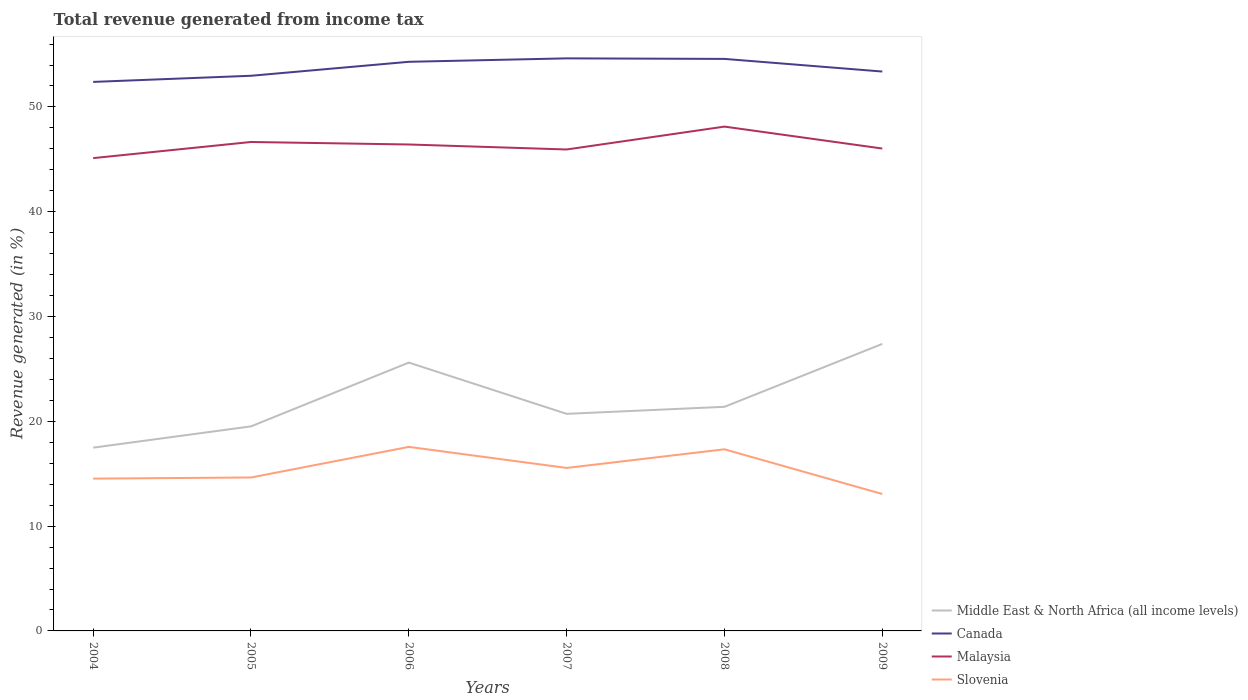How many different coloured lines are there?
Your answer should be compact. 4. Across all years, what is the maximum total revenue generated in Malaysia?
Your answer should be compact. 45.12. What is the total total revenue generated in Middle East & North Africa (all income levels) in the graph?
Ensure brevity in your answer.  -2.03. What is the difference between the highest and the second highest total revenue generated in Canada?
Keep it short and to the point. 2.25. What is the difference between the highest and the lowest total revenue generated in Canada?
Your response must be concise. 3. Is the total revenue generated in Malaysia strictly greater than the total revenue generated in Slovenia over the years?
Ensure brevity in your answer.  No. How many lines are there?
Offer a very short reply. 4. How many years are there in the graph?
Make the answer very short. 6. Are the values on the major ticks of Y-axis written in scientific E-notation?
Offer a very short reply. No. What is the title of the graph?
Offer a very short reply. Total revenue generated from income tax. What is the label or title of the Y-axis?
Keep it short and to the point. Revenue generated (in %). What is the Revenue generated (in %) in Middle East & North Africa (all income levels) in 2004?
Provide a short and direct response. 17.49. What is the Revenue generated (in %) of Canada in 2004?
Your response must be concise. 52.39. What is the Revenue generated (in %) in Malaysia in 2004?
Give a very brief answer. 45.12. What is the Revenue generated (in %) of Slovenia in 2004?
Keep it short and to the point. 14.53. What is the Revenue generated (in %) in Middle East & North Africa (all income levels) in 2005?
Make the answer very short. 19.52. What is the Revenue generated (in %) of Canada in 2005?
Your answer should be very brief. 52.97. What is the Revenue generated (in %) of Malaysia in 2005?
Ensure brevity in your answer.  46.66. What is the Revenue generated (in %) in Slovenia in 2005?
Your answer should be very brief. 14.64. What is the Revenue generated (in %) in Middle East & North Africa (all income levels) in 2006?
Make the answer very short. 25.61. What is the Revenue generated (in %) of Canada in 2006?
Make the answer very short. 54.31. What is the Revenue generated (in %) in Malaysia in 2006?
Offer a terse response. 46.42. What is the Revenue generated (in %) in Slovenia in 2006?
Your response must be concise. 17.56. What is the Revenue generated (in %) of Middle East & North Africa (all income levels) in 2007?
Provide a succinct answer. 20.71. What is the Revenue generated (in %) of Canada in 2007?
Make the answer very short. 54.64. What is the Revenue generated (in %) of Malaysia in 2007?
Your response must be concise. 45.94. What is the Revenue generated (in %) in Slovenia in 2007?
Give a very brief answer. 15.55. What is the Revenue generated (in %) of Middle East & North Africa (all income levels) in 2008?
Offer a very short reply. 21.38. What is the Revenue generated (in %) in Canada in 2008?
Give a very brief answer. 54.58. What is the Revenue generated (in %) of Malaysia in 2008?
Offer a very short reply. 48.12. What is the Revenue generated (in %) in Slovenia in 2008?
Offer a terse response. 17.33. What is the Revenue generated (in %) of Middle East & North Africa (all income levels) in 2009?
Your answer should be compact. 27.39. What is the Revenue generated (in %) of Canada in 2009?
Provide a succinct answer. 53.38. What is the Revenue generated (in %) in Malaysia in 2009?
Ensure brevity in your answer.  46.03. What is the Revenue generated (in %) in Slovenia in 2009?
Provide a succinct answer. 13.06. Across all years, what is the maximum Revenue generated (in %) of Middle East & North Africa (all income levels)?
Offer a terse response. 27.39. Across all years, what is the maximum Revenue generated (in %) of Canada?
Your response must be concise. 54.64. Across all years, what is the maximum Revenue generated (in %) of Malaysia?
Provide a short and direct response. 48.12. Across all years, what is the maximum Revenue generated (in %) in Slovenia?
Offer a terse response. 17.56. Across all years, what is the minimum Revenue generated (in %) in Middle East & North Africa (all income levels)?
Give a very brief answer. 17.49. Across all years, what is the minimum Revenue generated (in %) in Canada?
Ensure brevity in your answer.  52.39. Across all years, what is the minimum Revenue generated (in %) of Malaysia?
Give a very brief answer. 45.12. Across all years, what is the minimum Revenue generated (in %) in Slovenia?
Ensure brevity in your answer.  13.06. What is the total Revenue generated (in %) of Middle East & North Africa (all income levels) in the graph?
Make the answer very short. 132.1. What is the total Revenue generated (in %) of Canada in the graph?
Ensure brevity in your answer.  322.26. What is the total Revenue generated (in %) of Malaysia in the graph?
Give a very brief answer. 278.28. What is the total Revenue generated (in %) of Slovenia in the graph?
Provide a short and direct response. 92.68. What is the difference between the Revenue generated (in %) in Middle East & North Africa (all income levels) in 2004 and that in 2005?
Provide a short and direct response. -2.03. What is the difference between the Revenue generated (in %) in Canada in 2004 and that in 2005?
Give a very brief answer. -0.59. What is the difference between the Revenue generated (in %) of Malaysia in 2004 and that in 2005?
Ensure brevity in your answer.  -1.54. What is the difference between the Revenue generated (in %) of Slovenia in 2004 and that in 2005?
Offer a terse response. -0.11. What is the difference between the Revenue generated (in %) of Middle East & North Africa (all income levels) in 2004 and that in 2006?
Your response must be concise. -8.12. What is the difference between the Revenue generated (in %) of Canada in 2004 and that in 2006?
Your response must be concise. -1.92. What is the difference between the Revenue generated (in %) of Malaysia in 2004 and that in 2006?
Keep it short and to the point. -1.3. What is the difference between the Revenue generated (in %) in Slovenia in 2004 and that in 2006?
Give a very brief answer. -3.03. What is the difference between the Revenue generated (in %) of Middle East & North Africa (all income levels) in 2004 and that in 2007?
Keep it short and to the point. -3.23. What is the difference between the Revenue generated (in %) of Canada in 2004 and that in 2007?
Provide a succinct answer. -2.25. What is the difference between the Revenue generated (in %) of Malaysia in 2004 and that in 2007?
Keep it short and to the point. -0.82. What is the difference between the Revenue generated (in %) of Slovenia in 2004 and that in 2007?
Keep it short and to the point. -1.02. What is the difference between the Revenue generated (in %) in Middle East & North Africa (all income levels) in 2004 and that in 2008?
Provide a succinct answer. -3.9. What is the difference between the Revenue generated (in %) in Canada in 2004 and that in 2008?
Offer a very short reply. -2.19. What is the difference between the Revenue generated (in %) in Malaysia in 2004 and that in 2008?
Provide a succinct answer. -3.01. What is the difference between the Revenue generated (in %) in Slovenia in 2004 and that in 2008?
Give a very brief answer. -2.8. What is the difference between the Revenue generated (in %) in Middle East & North Africa (all income levels) in 2004 and that in 2009?
Ensure brevity in your answer.  -9.9. What is the difference between the Revenue generated (in %) of Canada in 2004 and that in 2009?
Offer a very short reply. -0.99. What is the difference between the Revenue generated (in %) in Malaysia in 2004 and that in 2009?
Provide a short and direct response. -0.91. What is the difference between the Revenue generated (in %) in Slovenia in 2004 and that in 2009?
Your answer should be compact. 1.47. What is the difference between the Revenue generated (in %) of Middle East & North Africa (all income levels) in 2005 and that in 2006?
Ensure brevity in your answer.  -6.09. What is the difference between the Revenue generated (in %) of Canada in 2005 and that in 2006?
Ensure brevity in your answer.  -1.33. What is the difference between the Revenue generated (in %) of Malaysia in 2005 and that in 2006?
Give a very brief answer. 0.24. What is the difference between the Revenue generated (in %) in Slovenia in 2005 and that in 2006?
Ensure brevity in your answer.  -2.92. What is the difference between the Revenue generated (in %) of Middle East & North Africa (all income levels) in 2005 and that in 2007?
Your response must be concise. -1.2. What is the difference between the Revenue generated (in %) of Canada in 2005 and that in 2007?
Provide a succinct answer. -1.66. What is the difference between the Revenue generated (in %) in Malaysia in 2005 and that in 2007?
Provide a succinct answer. 0.72. What is the difference between the Revenue generated (in %) in Slovenia in 2005 and that in 2007?
Offer a terse response. -0.91. What is the difference between the Revenue generated (in %) of Middle East & North Africa (all income levels) in 2005 and that in 2008?
Keep it short and to the point. -1.87. What is the difference between the Revenue generated (in %) in Canada in 2005 and that in 2008?
Provide a short and direct response. -1.61. What is the difference between the Revenue generated (in %) of Malaysia in 2005 and that in 2008?
Provide a succinct answer. -1.47. What is the difference between the Revenue generated (in %) of Slovenia in 2005 and that in 2008?
Make the answer very short. -2.69. What is the difference between the Revenue generated (in %) in Middle East & North Africa (all income levels) in 2005 and that in 2009?
Your response must be concise. -7.87. What is the difference between the Revenue generated (in %) in Canada in 2005 and that in 2009?
Offer a very short reply. -0.4. What is the difference between the Revenue generated (in %) in Malaysia in 2005 and that in 2009?
Give a very brief answer. 0.63. What is the difference between the Revenue generated (in %) in Slovenia in 2005 and that in 2009?
Provide a short and direct response. 1.58. What is the difference between the Revenue generated (in %) in Middle East & North Africa (all income levels) in 2006 and that in 2007?
Offer a very short reply. 4.89. What is the difference between the Revenue generated (in %) of Canada in 2006 and that in 2007?
Provide a succinct answer. -0.33. What is the difference between the Revenue generated (in %) of Malaysia in 2006 and that in 2007?
Keep it short and to the point. 0.48. What is the difference between the Revenue generated (in %) of Slovenia in 2006 and that in 2007?
Make the answer very short. 2.01. What is the difference between the Revenue generated (in %) in Middle East & North Africa (all income levels) in 2006 and that in 2008?
Provide a succinct answer. 4.22. What is the difference between the Revenue generated (in %) of Canada in 2006 and that in 2008?
Ensure brevity in your answer.  -0.28. What is the difference between the Revenue generated (in %) of Malaysia in 2006 and that in 2008?
Offer a very short reply. -1.71. What is the difference between the Revenue generated (in %) in Slovenia in 2006 and that in 2008?
Provide a succinct answer. 0.23. What is the difference between the Revenue generated (in %) of Middle East & North Africa (all income levels) in 2006 and that in 2009?
Provide a succinct answer. -1.78. What is the difference between the Revenue generated (in %) of Canada in 2006 and that in 2009?
Your response must be concise. 0.93. What is the difference between the Revenue generated (in %) in Malaysia in 2006 and that in 2009?
Give a very brief answer. 0.39. What is the difference between the Revenue generated (in %) in Slovenia in 2006 and that in 2009?
Provide a short and direct response. 4.5. What is the difference between the Revenue generated (in %) of Middle East & North Africa (all income levels) in 2007 and that in 2008?
Make the answer very short. -0.67. What is the difference between the Revenue generated (in %) in Canada in 2007 and that in 2008?
Your answer should be compact. 0.05. What is the difference between the Revenue generated (in %) in Malaysia in 2007 and that in 2008?
Offer a terse response. -2.18. What is the difference between the Revenue generated (in %) in Slovenia in 2007 and that in 2008?
Provide a succinct answer. -1.78. What is the difference between the Revenue generated (in %) in Middle East & North Africa (all income levels) in 2007 and that in 2009?
Make the answer very short. -6.67. What is the difference between the Revenue generated (in %) in Canada in 2007 and that in 2009?
Ensure brevity in your answer.  1.26. What is the difference between the Revenue generated (in %) in Malaysia in 2007 and that in 2009?
Make the answer very short. -0.09. What is the difference between the Revenue generated (in %) of Slovenia in 2007 and that in 2009?
Provide a succinct answer. 2.49. What is the difference between the Revenue generated (in %) of Middle East & North Africa (all income levels) in 2008 and that in 2009?
Make the answer very short. -6. What is the difference between the Revenue generated (in %) in Canada in 2008 and that in 2009?
Provide a succinct answer. 1.21. What is the difference between the Revenue generated (in %) in Malaysia in 2008 and that in 2009?
Provide a short and direct response. 2.09. What is the difference between the Revenue generated (in %) in Slovenia in 2008 and that in 2009?
Your answer should be compact. 4.27. What is the difference between the Revenue generated (in %) of Middle East & North Africa (all income levels) in 2004 and the Revenue generated (in %) of Canada in 2005?
Keep it short and to the point. -35.49. What is the difference between the Revenue generated (in %) of Middle East & North Africa (all income levels) in 2004 and the Revenue generated (in %) of Malaysia in 2005?
Provide a succinct answer. -29.17. What is the difference between the Revenue generated (in %) of Middle East & North Africa (all income levels) in 2004 and the Revenue generated (in %) of Slovenia in 2005?
Your answer should be compact. 2.85. What is the difference between the Revenue generated (in %) of Canada in 2004 and the Revenue generated (in %) of Malaysia in 2005?
Your response must be concise. 5.73. What is the difference between the Revenue generated (in %) in Canada in 2004 and the Revenue generated (in %) in Slovenia in 2005?
Offer a terse response. 37.75. What is the difference between the Revenue generated (in %) of Malaysia in 2004 and the Revenue generated (in %) of Slovenia in 2005?
Provide a short and direct response. 30.47. What is the difference between the Revenue generated (in %) of Middle East & North Africa (all income levels) in 2004 and the Revenue generated (in %) of Canada in 2006?
Offer a very short reply. -36.82. What is the difference between the Revenue generated (in %) in Middle East & North Africa (all income levels) in 2004 and the Revenue generated (in %) in Malaysia in 2006?
Offer a very short reply. -28.93. What is the difference between the Revenue generated (in %) in Middle East & North Africa (all income levels) in 2004 and the Revenue generated (in %) in Slovenia in 2006?
Your answer should be compact. -0.07. What is the difference between the Revenue generated (in %) of Canada in 2004 and the Revenue generated (in %) of Malaysia in 2006?
Offer a terse response. 5.97. What is the difference between the Revenue generated (in %) of Canada in 2004 and the Revenue generated (in %) of Slovenia in 2006?
Provide a succinct answer. 34.83. What is the difference between the Revenue generated (in %) of Malaysia in 2004 and the Revenue generated (in %) of Slovenia in 2006?
Offer a very short reply. 27.55. What is the difference between the Revenue generated (in %) in Middle East & North Africa (all income levels) in 2004 and the Revenue generated (in %) in Canada in 2007?
Your answer should be very brief. -37.15. What is the difference between the Revenue generated (in %) in Middle East & North Africa (all income levels) in 2004 and the Revenue generated (in %) in Malaysia in 2007?
Give a very brief answer. -28.45. What is the difference between the Revenue generated (in %) of Middle East & North Africa (all income levels) in 2004 and the Revenue generated (in %) of Slovenia in 2007?
Give a very brief answer. 1.94. What is the difference between the Revenue generated (in %) of Canada in 2004 and the Revenue generated (in %) of Malaysia in 2007?
Offer a terse response. 6.45. What is the difference between the Revenue generated (in %) in Canada in 2004 and the Revenue generated (in %) in Slovenia in 2007?
Provide a succinct answer. 36.84. What is the difference between the Revenue generated (in %) in Malaysia in 2004 and the Revenue generated (in %) in Slovenia in 2007?
Give a very brief answer. 29.56. What is the difference between the Revenue generated (in %) in Middle East & North Africa (all income levels) in 2004 and the Revenue generated (in %) in Canada in 2008?
Give a very brief answer. -37.1. What is the difference between the Revenue generated (in %) in Middle East & North Africa (all income levels) in 2004 and the Revenue generated (in %) in Malaysia in 2008?
Ensure brevity in your answer.  -30.64. What is the difference between the Revenue generated (in %) in Middle East & North Africa (all income levels) in 2004 and the Revenue generated (in %) in Slovenia in 2008?
Your answer should be very brief. 0.16. What is the difference between the Revenue generated (in %) in Canada in 2004 and the Revenue generated (in %) in Malaysia in 2008?
Ensure brevity in your answer.  4.26. What is the difference between the Revenue generated (in %) in Canada in 2004 and the Revenue generated (in %) in Slovenia in 2008?
Provide a short and direct response. 35.06. What is the difference between the Revenue generated (in %) of Malaysia in 2004 and the Revenue generated (in %) of Slovenia in 2008?
Ensure brevity in your answer.  27.78. What is the difference between the Revenue generated (in %) in Middle East & North Africa (all income levels) in 2004 and the Revenue generated (in %) in Canada in 2009?
Make the answer very short. -35.89. What is the difference between the Revenue generated (in %) in Middle East & North Africa (all income levels) in 2004 and the Revenue generated (in %) in Malaysia in 2009?
Ensure brevity in your answer.  -28.54. What is the difference between the Revenue generated (in %) in Middle East & North Africa (all income levels) in 2004 and the Revenue generated (in %) in Slovenia in 2009?
Your answer should be compact. 4.42. What is the difference between the Revenue generated (in %) of Canada in 2004 and the Revenue generated (in %) of Malaysia in 2009?
Your answer should be compact. 6.36. What is the difference between the Revenue generated (in %) in Canada in 2004 and the Revenue generated (in %) in Slovenia in 2009?
Provide a short and direct response. 39.32. What is the difference between the Revenue generated (in %) in Malaysia in 2004 and the Revenue generated (in %) in Slovenia in 2009?
Your answer should be compact. 32.05. What is the difference between the Revenue generated (in %) in Middle East & North Africa (all income levels) in 2005 and the Revenue generated (in %) in Canada in 2006?
Your response must be concise. -34.79. What is the difference between the Revenue generated (in %) in Middle East & North Africa (all income levels) in 2005 and the Revenue generated (in %) in Malaysia in 2006?
Offer a very short reply. -26.9. What is the difference between the Revenue generated (in %) of Middle East & North Africa (all income levels) in 2005 and the Revenue generated (in %) of Slovenia in 2006?
Make the answer very short. 1.96. What is the difference between the Revenue generated (in %) of Canada in 2005 and the Revenue generated (in %) of Malaysia in 2006?
Ensure brevity in your answer.  6.56. What is the difference between the Revenue generated (in %) in Canada in 2005 and the Revenue generated (in %) in Slovenia in 2006?
Your answer should be very brief. 35.41. What is the difference between the Revenue generated (in %) in Malaysia in 2005 and the Revenue generated (in %) in Slovenia in 2006?
Your response must be concise. 29.09. What is the difference between the Revenue generated (in %) of Middle East & North Africa (all income levels) in 2005 and the Revenue generated (in %) of Canada in 2007?
Offer a very short reply. -35.12. What is the difference between the Revenue generated (in %) of Middle East & North Africa (all income levels) in 2005 and the Revenue generated (in %) of Malaysia in 2007?
Offer a terse response. -26.42. What is the difference between the Revenue generated (in %) in Middle East & North Africa (all income levels) in 2005 and the Revenue generated (in %) in Slovenia in 2007?
Your answer should be compact. 3.96. What is the difference between the Revenue generated (in %) of Canada in 2005 and the Revenue generated (in %) of Malaysia in 2007?
Your answer should be very brief. 7.03. What is the difference between the Revenue generated (in %) of Canada in 2005 and the Revenue generated (in %) of Slovenia in 2007?
Offer a terse response. 37.42. What is the difference between the Revenue generated (in %) of Malaysia in 2005 and the Revenue generated (in %) of Slovenia in 2007?
Make the answer very short. 31.1. What is the difference between the Revenue generated (in %) in Middle East & North Africa (all income levels) in 2005 and the Revenue generated (in %) in Canada in 2008?
Ensure brevity in your answer.  -35.07. What is the difference between the Revenue generated (in %) of Middle East & North Africa (all income levels) in 2005 and the Revenue generated (in %) of Malaysia in 2008?
Keep it short and to the point. -28.61. What is the difference between the Revenue generated (in %) of Middle East & North Africa (all income levels) in 2005 and the Revenue generated (in %) of Slovenia in 2008?
Provide a succinct answer. 2.19. What is the difference between the Revenue generated (in %) of Canada in 2005 and the Revenue generated (in %) of Malaysia in 2008?
Make the answer very short. 4.85. What is the difference between the Revenue generated (in %) of Canada in 2005 and the Revenue generated (in %) of Slovenia in 2008?
Provide a succinct answer. 35.64. What is the difference between the Revenue generated (in %) in Malaysia in 2005 and the Revenue generated (in %) in Slovenia in 2008?
Your response must be concise. 29.32. What is the difference between the Revenue generated (in %) of Middle East & North Africa (all income levels) in 2005 and the Revenue generated (in %) of Canada in 2009?
Offer a very short reply. -33.86. What is the difference between the Revenue generated (in %) in Middle East & North Africa (all income levels) in 2005 and the Revenue generated (in %) in Malaysia in 2009?
Ensure brevity in your answer.  -26.51. What is the difference between the Revenue generated (in %) of Middle East & North Africa (all income levels) in 2005 and the Revenue generated (in %) of Slovenia in 2009?
Ensure brevity in your answer.  6.45. What is the difference between the Revenue generated (in %) in Canada in 2005 and the Revenue generated (in %) in Malaysia in 2009?
Give a very brief answer. 6.94. What is the difference between the Revenue generated (in %) in Canada in 2005 and the Revenue generated (in %) in Slovenia in 2009?
Your response must be concise. 39.91. What is the difference between the Revenue generated (in %) of Malaysia in 2005 and the Revenue generated (in %) of Slovenia in 2009?
Your answer should be compact. 33.59. What is the difference between the Revenue generated (in %) of Middle East & North Africa (all income levels) in 2006 and the Revenue generated (in %) of Canada in 2007?
Provide a short and direct response. -29.03. What is the difference between the Revenue generated (in %) of Middle East & North Africa (all income levels) in 2006 and the Revenue generated (in %) of Malaysia in 2007?
Make the answer very short. -20.33. What is the difference between the Revenue generated (in %) of Middle East & North Africa (all income levels) in 2006 and the Revenue generated (in %) of Slovenia in 2007?
Your answer should be compact. 10.05. What is the difference between the Revenue generated (in %) in Canada in 2006 and the Revenue generated (in %) in Malaysia in 2007?
Offer a terse response. 8.37. What is the difference between the Revenue generated (in %) of Canada in 2006 and the Revenue generated (in %) of Slovenia in 2007?
Your answer should be very brief. 38.75. What is the difference between the Revenue generated (in %) in Malaysia in 2006 and the Revenue generated (in %) in Slovenia in 2007?
Provide a succinct answer. 30.86. What is the difference between the Revenue generated (in %) of Middle East & North Africa (all income levels) in 2006 and the Revenue generated (in %) of Canada in 2008?
Make the answer very short. -28.98. What is the difference between the Revenue generated (in %) of Middle East & North Africa (all income levels) in 2006 and the Revenue generated (in %) of Malaysia in 2008?
Provide a succinct answer. -22.52. What is the difference between the Revenue generated (in %) of Middle East & North Africa (all income levels) in 2006 and the Revenue generated (in %) of Slovenia in 2008?
Give a very brief answer. 8.27. What is the difference between the Revenue generated (in %) of Canada in 2006 and the Revenue generated (in %) of Malaysia in 2008?
Ensure brevity in your answer.  6.18. What is the difference between the Revenue generated (in %) in Canada in 2006 and the Revenue generated (in %) in Slovenia in 2008?
Your answer should be compact. 36.98. What is the difference between the Revenue generated (in %) in Malaysia in 2006 and the Revenue generated (in %) in Slovenia in 2008?
Offer a terse response. 29.09. What is the difference between the Revenue generated (in %) in Middle East & North Africa (all income levels) in 2006 and the Revenue generated (in %) in Canada in 2009?
Your answer should be compact. -27.77. What is the difference between the Revenue generated (in %) of Middle East & North Africa (all income levels) in 2006 and the Revenue generated (in %) of Malaysia in 2009?
Offer a terse response. -20.42. What is the difference between the Revenue generated (in %) in Middle East & North Africa (all income levels) in 2006 and the Revenue generated (in %) in Slovenia in 2009?
Provide a succinct answer. 12.54. What is the difference between the Revenue generated (in %) of Canada in 2006 and the Revenue generated (in %) of Malaysia in 2009?
Your response must be concise. 8.28. What is the difference between the Revenue generated (in %) in Canada in 2006 and the Revenue generated (in %) in Slovenia in 2009?
Keep it short and to the point. 41.24. What is the difference between the Revenue generated (in %) of Malaysia in 2006 and the Revenue generated (in %) of Slovenia in 2009?
Offer a terse response. 33.35. What is the difference between the Revenue generated (in %) of Middle East & North Africa (all income levels) in 2007 and the Revenue generated (in %) of Canada in 2008?
Provide a short and direct response. -33.87. What is the difference between the Revenue generated (in %) in Middle East & North Africa (all income levels) in 2007 and the Revenue generated (in %) in Malaysia in 2008?
Your response must be concise. -27.41. What is the difference between the Revenue generated (in %) of Middle East & North Africa (all income levels) in 2007 and the Revenue generated (in %) of Slovenia in 2008?
Your answer should be very brief. 3.38. What is the difference between the Revenue generated (in %) of Canada in 2007 and the Revenue generated (in %) of Malaysia in 2008?
Your answer should be compact. 6.51. What is the difference between the Revenue generated (in %) in Canada in 2007 and the Revenue generated (in %) in Slovenia in 2008?
Your answer should be compact. 37.3. What is the difference between the Revenue generated (in %) in Malaysia in 2007 and the Revenue generated (in %) in Slovenia in 2008?
Keep it short and to the point. 28.61. What is the difference between the Revenue generated (in %) in Middle East & North Africa (all income levels) in 2007 and the Revenue generated (in %) in Canada in 2009?
Offer a very short reply. -32.66. What is the difference between the Revenue generated (in %) of Middle East & North Africa (all income levels) in 2007 and the Revenue generated (in %) of Malaysia in 2009?
Your response must be concise. -25.32. What is the difference between the Revenue generated (in %) of Middle East & North Africa (all income levels) in 2007 and the Revenue generated (in %) of Slovenia in 2009?
Give a very brief answer. 7.65. What is the difference between the Revenue generated (in %) of Canada in 2007 and the Revenue generated (in %) of Malaysia in 2009?
Your answer should be compact. 8.61. What is the difference between the Revenue generated (in %) of Canada in 2007 and the Revenue generated (in %) of Slovenia in 2009?
Provide a succinct answer. 41.57. What is the difference between the Revenue generated (in %) in Malaysia in 2007 and the Revenue generated (in %) in Slovenia in 2009?
Provide a short and direct response. 32.88. What is the difference between the Revenue generated (in %) in Middle East & North Africa (all income levels) in 2008 and the Revenue generated (in %) in Canada in 2009?
Make the answer very short. -31.99. What is the difference between the Revenue generated (in %) in Middle East & North Africa (all income levels) in 2008 and the Revenue generated (in %) in Malaysia in 2009?
Make the answer very short. -24.64. What is the difference between the Revenue generated (in %) in Middle East & North Africa (all income levels) in 2008 and the Revenue generated (in %) in Slovenia in 2009?
Ensure brevity in your answer.  8.32. What is the difference between the Revenue generated (in %) of Canada in 2008 and the Revenue generated (in %) of Malaysia in 2009?
Provide a short and direct response. 8.55. What is the difference between the Revenue generated (in %) in Canada in 2008 and the Revenue generated (in %) in Slovenia in 2009?
Offer a terse response. 41.52. What is the difference between the Revenue generated (in %) of Malaysia in 2008 and the Revenue generated (in %) of Slovenia in 2009?
Offer a very short reply. 35.06. What is the average Revenue generated (in %) of Middle East & North Africa (all income levels) per year?
Keep it short and to the point. 22.02. What is the average Revenue generated (in %) of Canada per year?
Provide a succinct answer. 53.71. What is the average Revenue generated (in %) of Malaysia per year?
Provide a succinct answer. 46.38. What is the average Revenue generated (in %) in Slovenia per year?
Make the answer very short. 15.45. In the year 2004, what is the difference between the Revenue generated (in %) in Middle East & North Africa (all income levels) and Revenue generated (in %) in Canada?
Keep it short and to the point. -34.9. In the year 2004, what is the difference between the Revenue generated (in %) in Middle East & North Africa (all income levels) and Revenue generated (in %) in Malaysia?
Offer a very short reply. -27.63. In the year 2004, what is the difference between the Revenue generated (in %) in Middle East & North Africa (all income levels) and Revenue generated (in %) in Slovenia?
Keep it short and to the point. 2.96. In the year 2004, what is the difference between the Revenue generated (in %) in Canada and Revenue generated (in %) in Malaysia?
Offer a terse response. 7.27. In the year 2004, what is the difference between the Revenue generated (in %) in Canada and Revenue generated (in %) in Slovenia?
Provide a short and direct response. 37.86. In the year 2004, what is the difference between the Revenue generated (in %) in Malaysia and Revenue generated (in %) in Slovenia?
Your answer should be very brief. 30.58. In the year 2005, what is the difference between the Revenue generated (in %) in Middle East & North Africa (all income levels) and Revenue generated (in %) in Canada?
Give a very brief answer. -33.46. In the year 2005, what is the difference between the Revenue generated (in %) of Middle East & North Africa (all income levels) and Revenue generated (in %) of Malaysia?
Ensure brevity in your answer.  -27.14. In the year 2005, what is the difference between the Revenue generated (in %) of Middle East & North Africa (all income levels) and Revenue generated (in %) of Slovenia?
Ensure brevity in your answer.  4.88. In the year 2005, what is the difference between the Revenue generated (in %) in Canada and Revenue generated (in %) in Malaysia?
Offer a terse response. 6.32. In the year 2005, what is the difference between the Revenue generated (in %) in Canada and Revenue generated (in %) in Slovenia?
Offer a very short reply. 38.33. In the year 2005, what is the difference between the Revenue generated (in %) in Malaysia and Revenue generated (in %) in Slovenia?
Give a very brief answer. 32.01. In the year 2006, what is the difference between the Revenue generated (in %) of Middle East & North Africa (all income levels) and Revenue generated (in %) of Canada?
Your answer should be very brief. -28.7. In the year 2006, what is the difference between the Revenue generated (in %) in Middle East & North Africa (all income levels) and Revenue generated (in %) in Malaysia?
Make the answer very short. -20.81. In the year 2006, what is the difference between the Revenue generated (in %) of Middle East & North Africa (all income levels) and Revenue generated (in %) of Slovenia?
Ensure brevity in your answer.  8.04. In the year 2006, what is the difference between the Revenue generated (in %) in Canada and Revenue generated (in %) in Malaysia?
Your answer should be very brief. 7.89. In the year 2006, what is the difference between the Revenue generated (in %) of Canada and Revenue generated (in %) of Slovenia?
Your response must be concise. 36.75. In the year 2006, what is the difference between the Revenue generated (in %) in Malaysia and Revenue generated (in %) in Slovenia?
Keep it short and to the point. 28.86. In the year 2007, what is the difference between the Revenue generated (in %) in Middle East & North Africa (all income levels) and Revenue generated (in %) in Canada?
Ensure brevity in your answer.  -33.92. In the year 2007, what is the difference between the Revenue generated (in %) of Middle East & North Africa (all income levels) and Revenue generated (in %) of Malaysia?
Provide a succinct answer. -25.23. In the year 2007, what is the difference between the Revenue generated (in %) of Middle East & North Africa (all income levels) and Revenue generated (in %) of Slovenia?
Your answer should be compact. 5.16. In the year 2007, what is the difference between the Revenue generated (in %) in Canada and Revenue generated (in %) in Malaysia?
Provide a succinct answer. 8.7. In the year 2007, what is the difference between the Revenue generated (in %) of Canada and Revenue generated (in %) of Slovenia?
Offer a terse response. 39.08. In the year 2007, what is the difference between the Revenue generated (in %) of Malaysia and Revenue generated (in %) of Slovenia?
Keep it short and to the point. 30.39. In the year 2008, what is the difference between the Revenue generated (in %) in Middle East & North Africa (all income levels) and Revenue generated (in %) in Canada?
Keep it short and to the point. -33.2. In the year 2008, what is the difference between the Revenue generated (in %) in Middle East & North Africa (all income levels) and Revenue generated (in %) in Malaysia?
Offer a very short reply. -26.74. In the year 2008, what is the difference between the Revenue generated (in %) in Middle East & North Africa (all income levels) and Revenue generated (in %) in Slovenia?
Ensure brevity in your answer.  4.05. In the year 2008, what is the difference between the Revenue generated (in %) in Canada and Revenue generated (in %) in Malaysia?
Make the answer very short. 6.46. In the year 2008, what is the difference between the Revenue generated (in %) of Canada and Revenue generated (in %) of Slovenia?
Keep it short and to the point. 37.25. In the year 2008, what is the difference between the Revenue generated (in %) of Malaysia and Revenue generated (in %) of Slovenia?
Your answer should be compact. 30.79. In the year 2009, what is the difference between the Revenue generated (in %) of Middle East & North Africa (all income levels) and Revenue generated (in %) of Canada?
Your answer should be very brief. -25.99. In the year 2009, what is the difference between the Revenue generated (in %) of Middle East & North Africa (all income levels) and Revenue generated (in %) of Malaysia?
Provide a short and direct response. -18.64. In the year 2009, what is the difference between the Revenue generated (in %) in Middle East & North Africa (all income levels) and Revenue generated (in %) in Slovenia?
Offer a terse response. 14.32. In the year 2009, what is the difference between the Revenue generated (in %) of Canada and Revenue generated (in %) of Malaysia?
Make the answer very short. 7.35. In the year 2009, what is the difference between the Revenue generated (in %) of Canada and Revenue generated (in %) of Slovenia?
Give a very brief answer. 40.31. In the year 2009, what is the difference between the Revenue generated (in %) in Malaysia and Revenue generated (in %) in Slovenia?
Give a very brief answer. 32.97. What is the ratio of the Revenue generated (in %) of Middle East & North Africa (all income levels) in 2004 to that in 2005?
Your answer should be compact. 0.9. What is the ratio of the Revenue generated (in %) of Malaysia in 2004 to that in 2005?
Make the answer very short. 0.97. What is the ratio of the Revenue generated (in %) in Slovenia in 2004 to that in 2005?
Offer a terse response. 0.99. What is the ratio of the Revenue generated (in %) in Middle East & North Africa (all income levels) in 2004 to that in 2006?
Provide a succinct answer. 0.68. What is the ratio of the Revenue generated (in %) of Canada in 2004 to that in 2006?
Your response must be concise. 0.96. What is the ratio of the Revenue generated (in %) of Slovenia in 2004 to that in 2006?
Your response must be concise. 0.83. What is the ratio of the Revenue generated (in %) of Middle East & North Africa (all income levels) in 2004 to that in 2007?
Give a very brief answer. 0.84. What is the ratio of the Revenue generated (in %) of Canada in 2004 to that in 2007?
Your answer should be compact. 0.96. What is the ratio of the Revenue generated (in %) of Malaysia in 2004 to that in 2007?
Ensure brevity in your answer.  0.98. What is the ratio of the Revenue generated (in %) in Slovenia in 2004 to that in 2007?
Provide a succinct answer. 0.93. What is the ratio of the Revenue generated (in %) of Middle East & North Africa (all income levels) in 2004 to that in 2008?
Provide a succinct answer. 0.82. What is the ratio of the Revenue generated (in %) of Canada in 2004 to that in 2008?
Your response must be concise. 0.96. What is the ratio of the Revenue generated (in %) in Slovenia in 2004 to that in 2008?
Keep it short and to the point. 0.84. What is the ratio of the Revenue generated (in %) of Middle East & North Africa (all income levels) in 2004 to that in 2009?
Your response must be concise. 0.64. What is the ratio of the Revenue generated (in %) in Canada in 2004 to that in 2009?
Provide a short and direct response. 0.98. What is the ratio of the Revenue generated (in %) of Malaysia in 2004 to that in 2009?
Provide a short and direct response. 0.98. What is the ratio of the Revenue generated (in %) in Slovenia in 2004 to that in 2009?
Your answer should be compact. 1.11. What is the ratio of the Revenue generated (in %) in Middle East & North Africa (all income levels) in 2005 to that in 2006?
Provide a succinct answer. 0.76. What is the ratio of the Revenue generated (in %) in Canada in 2005 to that in 2006?
Make the answer very short. 0.98. What is the ratio of the Revenue generated (in %) of Malaysia in 2005 to that in 2006?
Your answer should be very brief. 1.01. What is the ratio of the Revenue generated (in %) of Slovenia in 2005 to that in 2006?
Provide a short and direct response. 0.83. What is the ratio of the Revenue generated (in %) of Middle East & North Africa (all income levels) in 2005 to that in 2007?
Offer a terse response. 0.94. What is the ratio of the Revenue generated (in %) of Canada in 2005 to that in 2007?
Keep it short and to the point. 0.97. What is the ratio of the Revenue generated (in %) of Malaysia in 2005 to that in 2007?
Make the answer very short. 1.02. What is the ratio of the Revenue generated (in %) in Slovenia in 2005 to that in 2007?
Give a very brief answer. 0.94. What is the ratio of the Revenue generated (in %) in Middle East & North Africa (all income levels) in 2005 to that in 2008?
Give a very brief answer. 0.91. What is the ratio of the Revenue generated (in %) of Canada in 2005 to that in 2008?
Your response must be concise. 0.97. What is the ratio of the Revenue generated (in %) of Malaysia in 2005 to that in 2008?
Offer a terse response. 0.97. What is the ratio of the Revenue generated (in %) in Slovenia in 2005 to that in 2008?
Your answer should be compact. 0.84. What is the ratio of the Revenue generated (in %) in Middle East & North Africa (all income levels) in 2005 to that in 2009?
Your response must be concise. 0.71. What is the ratio of the Revenue generated (in %) in Malaysia in 2005 to that in 2009?
Make the answer very short. 1.01. What is the ratio of the Revenue generated (in %) of Slovenia in 2005 to that in 2009?
Keep it short and to the point. 1.12. What is the ratio of the Revenue generated (in %) of Middle East & North Africa (all income levels) in 2006 to that in 2007?
Keep it short and to the point. 1.24. What is the ratio of the Revenue generated (in %) of Canada in 2006 to that in 2007?
Your answer should be very brief. 0.99. What is the ratio of the Revenue generated (in %) in Malaysia in 2006 to that in 2007?
Provide a succinct answer. 1.01. What is the ratio of the Revenue generated (in %) of Slovenia in 2006 to that in 2007?
Offer a very short reply. 1.13. What is the ratio of the Revenue generated (in %) of Middle East & North Africa (all income levels) in 2006 to that in 2008?
Give a very brief answer. 1.2. What is the ratio of the Revenue generated (in %) of Malaysia in 2006 to that in 2008?
Give a very brief answer. 0.96. What is the ratio of the Revenue generated (in %) in Slovenia in 2006 to that in 2008?
Provide a short and direct response. 1.01. What is the ratio of the Revenue generated (in %) in Middle East & North Africa (all income levels) in 2006 to that in 2009?
Provide a succinct answer. 0.94. What is the ratio of the Revenue generated (in %) in Canada in 2006 to that in 2009?
Provide a succinct answer. 1.02. What is the ratio of the Revenue generated (in %) of Malaysia in 2006 to that in 2009?
Offer a terse response. 1.01. What is the ratio of the Revenue generated (in %) of Slovenia in 2006 to that in 2009?
Ensure brevity in your answer.  1.34. What is the ratio of the Revenue generated (in %) of Middle East & North Africa (all income levels) in 2007 to that in 2008?
Your answer should be very brief. 0.97. What is the ratio of the Revenue generated (in %) in Canada in 2007 to that in 2008?
Your response must be concise. 1. What is the ratio of the Revenue generated (in %) in Malaysia in 2007 to that in 2008?
Give a very brief answer. 0.95. What is the ratio of the Revenue generated (in %) of Slovenia in 2007 to that in 2008?
Ensure brevity in your answer.  0.9. What is the ratio of the Revenue generated (in %) of Middle East & North Africa (all income levels) in 2007 to that in 2009?
Keep it short and to the point. 0.76. What is the ratio of the Revenue generated (in %) of Canada in 2007 to that in 2009?
Offer a terse response. 1.02. What is the ratio of the Revenue generated (in %) of Slovenia in 2007 to that in 2009?
Provide a succinct answer. 1.19. What is the ratio of the Revenue generated (in %) in Middle East & North Africa (all income levels) in 2008 to that in 2009?
Your answer should be very brief. 0.78. What is the ratio of the Revenue generated (in %) of Canada in 2008 to that in 2009?
Provide a succinct answer. 1.02. What is the ratio of the Revenue generated (in %) of Malaysia in 2008 to that in 2009?
Offer a terse response. 1.05. What is the ratio of the Revenue generated (in %) of Slovenia in 2008 to that in 2009?
Keep it short and to the point. 1.33. What is the difference between the highest and the second highest Revenue generated (in %) in Middle East & North Africa (all income levels)?
Your answer should be compact. 1.78. What is the difference between the highest and the second highest Revenue generated (in %) in Canada?
Your answer should be very brief. 0.05. What is the difference between the highest and the second highest Revenue generated (in %) of Malaysia?
Provide a short and direct response. 1.47. What is the difference between the highest and the second highest Revenue generated (in %) in Slovenia?
Ensure brevity in your answer.  0.23. What is the difference between the highest and the lowest Revenue generated (in %) in Middle East & North Africa (all income levels)?
Keep it short and to the point. 9.9. What is the difference between the highest and the lowest Revenue generated (in %) in Canada?
Offer a very short reply. 2.25. What is the difference between the highest and the lowest Revenue generated (in %) in Malaysia?
Give a very brief answer. 3.01. What is the difference between the highest and the lowest Revenue generated (in %) of Slovenia?
Give a very brief answer. 4.5. 